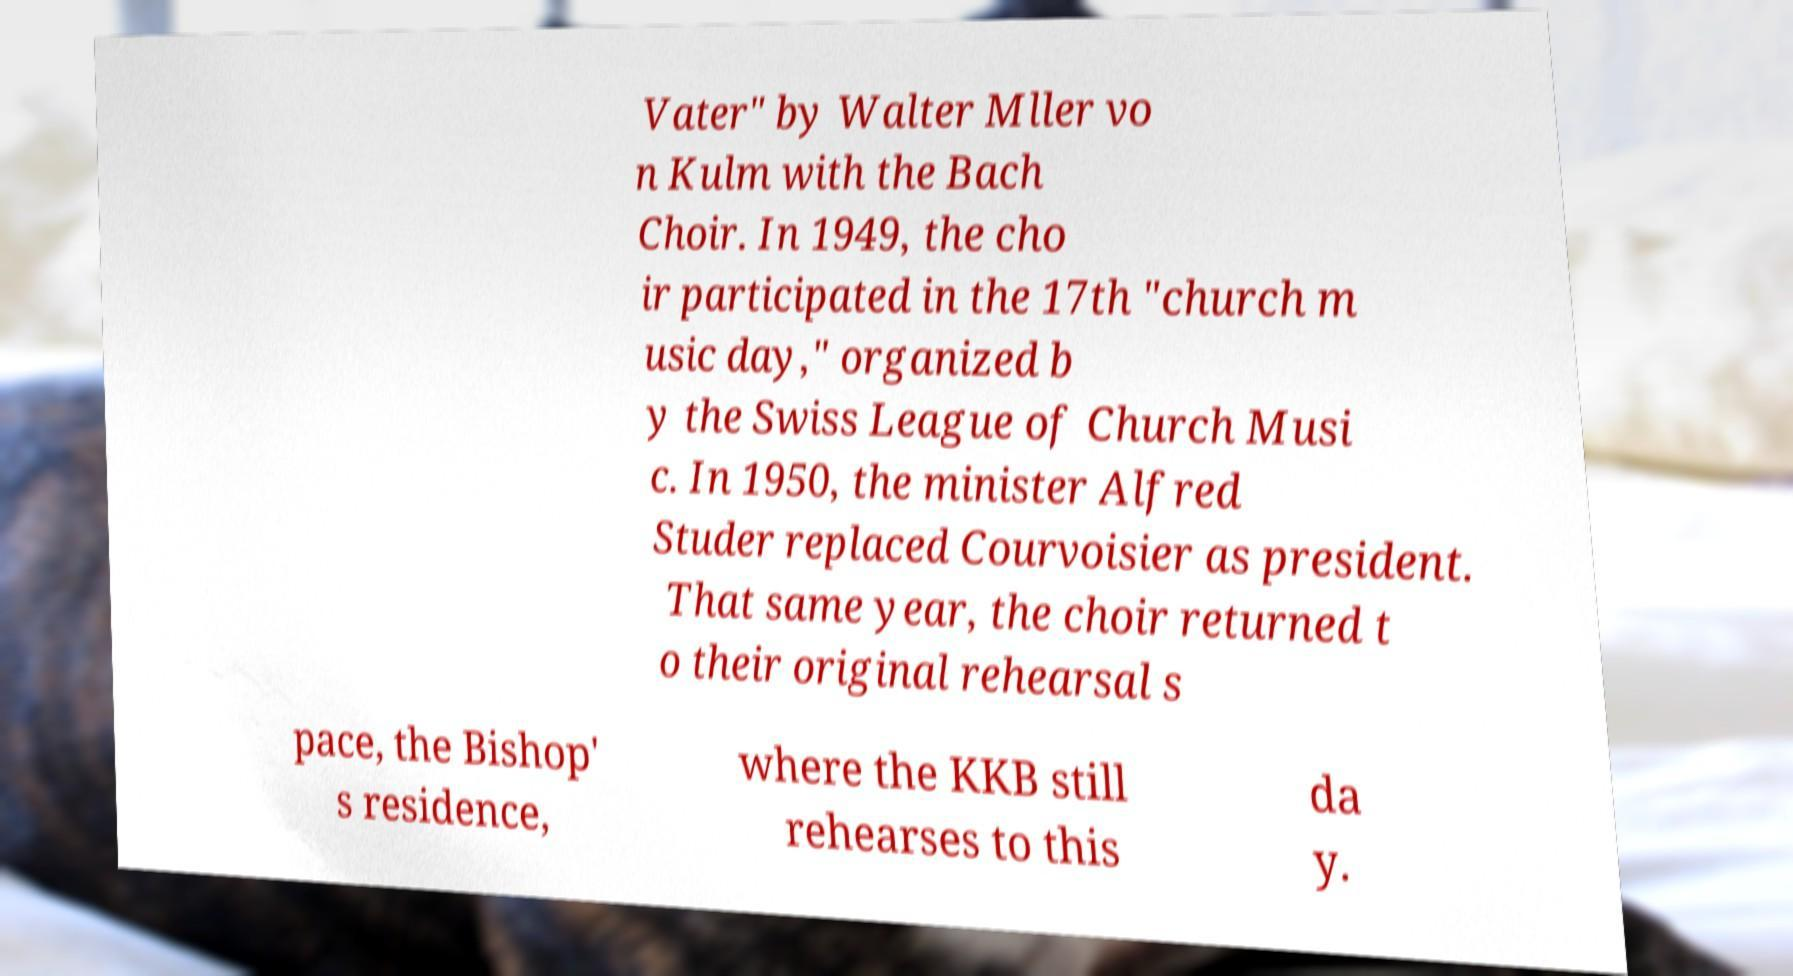Can you accurately transcribe the text from the provided image for me? Vater" by Walter Mller vo n Kulm with the Bach Choir. In 1949, the cho ir participated in the 17th "church m usic day," organized b y the Swiss League of Church Musi c. In 1950, the minister Alfred Studer replaced Courvoisier as president. That same year, the choir returned t o their original rehearsal s pace, the Bishop' s residence, where the KKB still rehearses to this da y. 